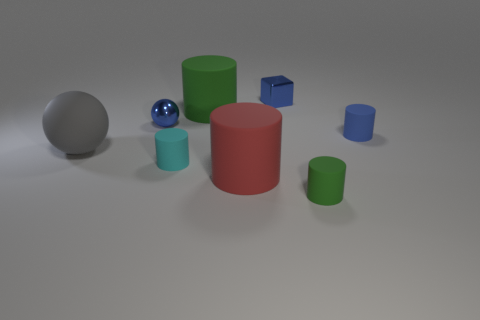There is a green matte object that is behind the cyan matte cylinder; is it the same shape as the gray matte thing?
Offer a terse response. No. There is a cylinder that is the same color as the tiny metal block; what is its size?
Offer a very short reply. Small. Is there a shiny cube that has the same size as the red thing?
Give a very brief answer. No. There is a large rubber object that is in front of the large object on the left side of the big green matte cylinder; is there a large matte cylinder in front of it?
Your response must be concise. No. There is a metal sphere; does it have the same color as the large matte cylinder that is behind the blue matte cylinder?
Keep it short and to the point. No. What is the material of the blue thing that is behind the green cylinder that is on the left side of the big red cylinder that is in front of the metallic block?
Ensure brevity in your answer.  Metal. What shape is the blue thing that is to the left of the red cylinder?
Keep it short and to the point. Sphere. There is a red object that is the same material as the blue cylinder; what is its size?
Give a very brief answer. Large. What number of small green objects have the same shape as the small blue matte object?
Ensure brevity in your answer.  1. There is a small metallic object that is right of the metallic sphere; is it the same color as the big sphere?
Provide a short and direct response. No. 